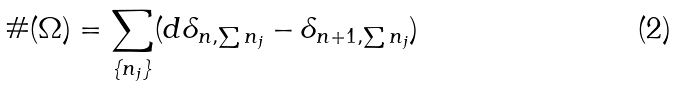<formula> <loc_0><loc_0><loc_500><loc_500>\# ( \Omega ) = \sum _ { \{ n _ { j } \} } ( d \delta _ { n , \sum n _ { j } } - \delta _ { n + 1 , \sum n _ { j } } )</formula> 